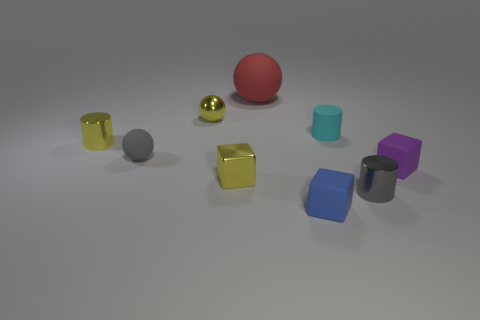There is a block that is both behind the small gray cylinder and on the left side of the gray metal cylinder; what size is it?
Your answer should be compact. Small. Are there any other cylinders that have the same size as the yellow cylinder?
Keep it short and to the point. Yes. Are there more big rubber balls that are right of the large thing than yellow balls to the left of the purple object?
Offer a terse response. No. Does the cyan cylinder have the same material as the tiny sphere in front of the tiny cyan rubber cylinder?
Your response must be concise. Yes. There is a tiny gray object behind the cube on the left side of the blue cube; what number of gray shiny objects are left of it?
Your answer should be very brief. 0. Do the big thing and the small yellow object that is behind the tiny yellow metallic cylinder have the same shape?
Offer a very short reply. Yes. There is a metallic object that is in front of the yellow cylinder and left of the cyan object; what color is it?
Provide a succinct answer. Yellow. There is a gray thing that is behind the tiny gray thing on the right side of the small rubber thing in front of the small purple rubber block; what is its material?
Provide a short and direct response. Rubber. What is the material of the yellow cube?
Give a very brief answer. Metal. What is the size of the red rubber thing that is the same shape as the small gray rubber object?
Offer a very short reply. Large. 